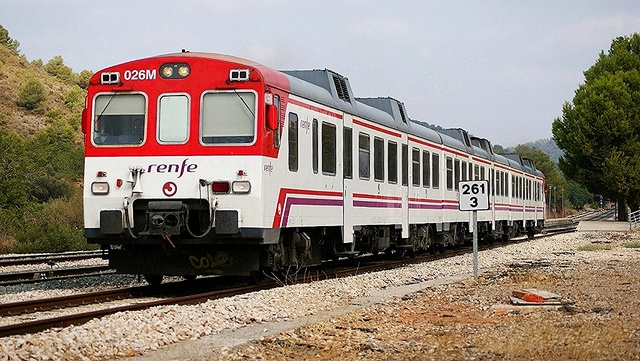Describe the objects in this image and their specific colors. I can see a train in lightgray, black, darkgray, and red tones in this image. 